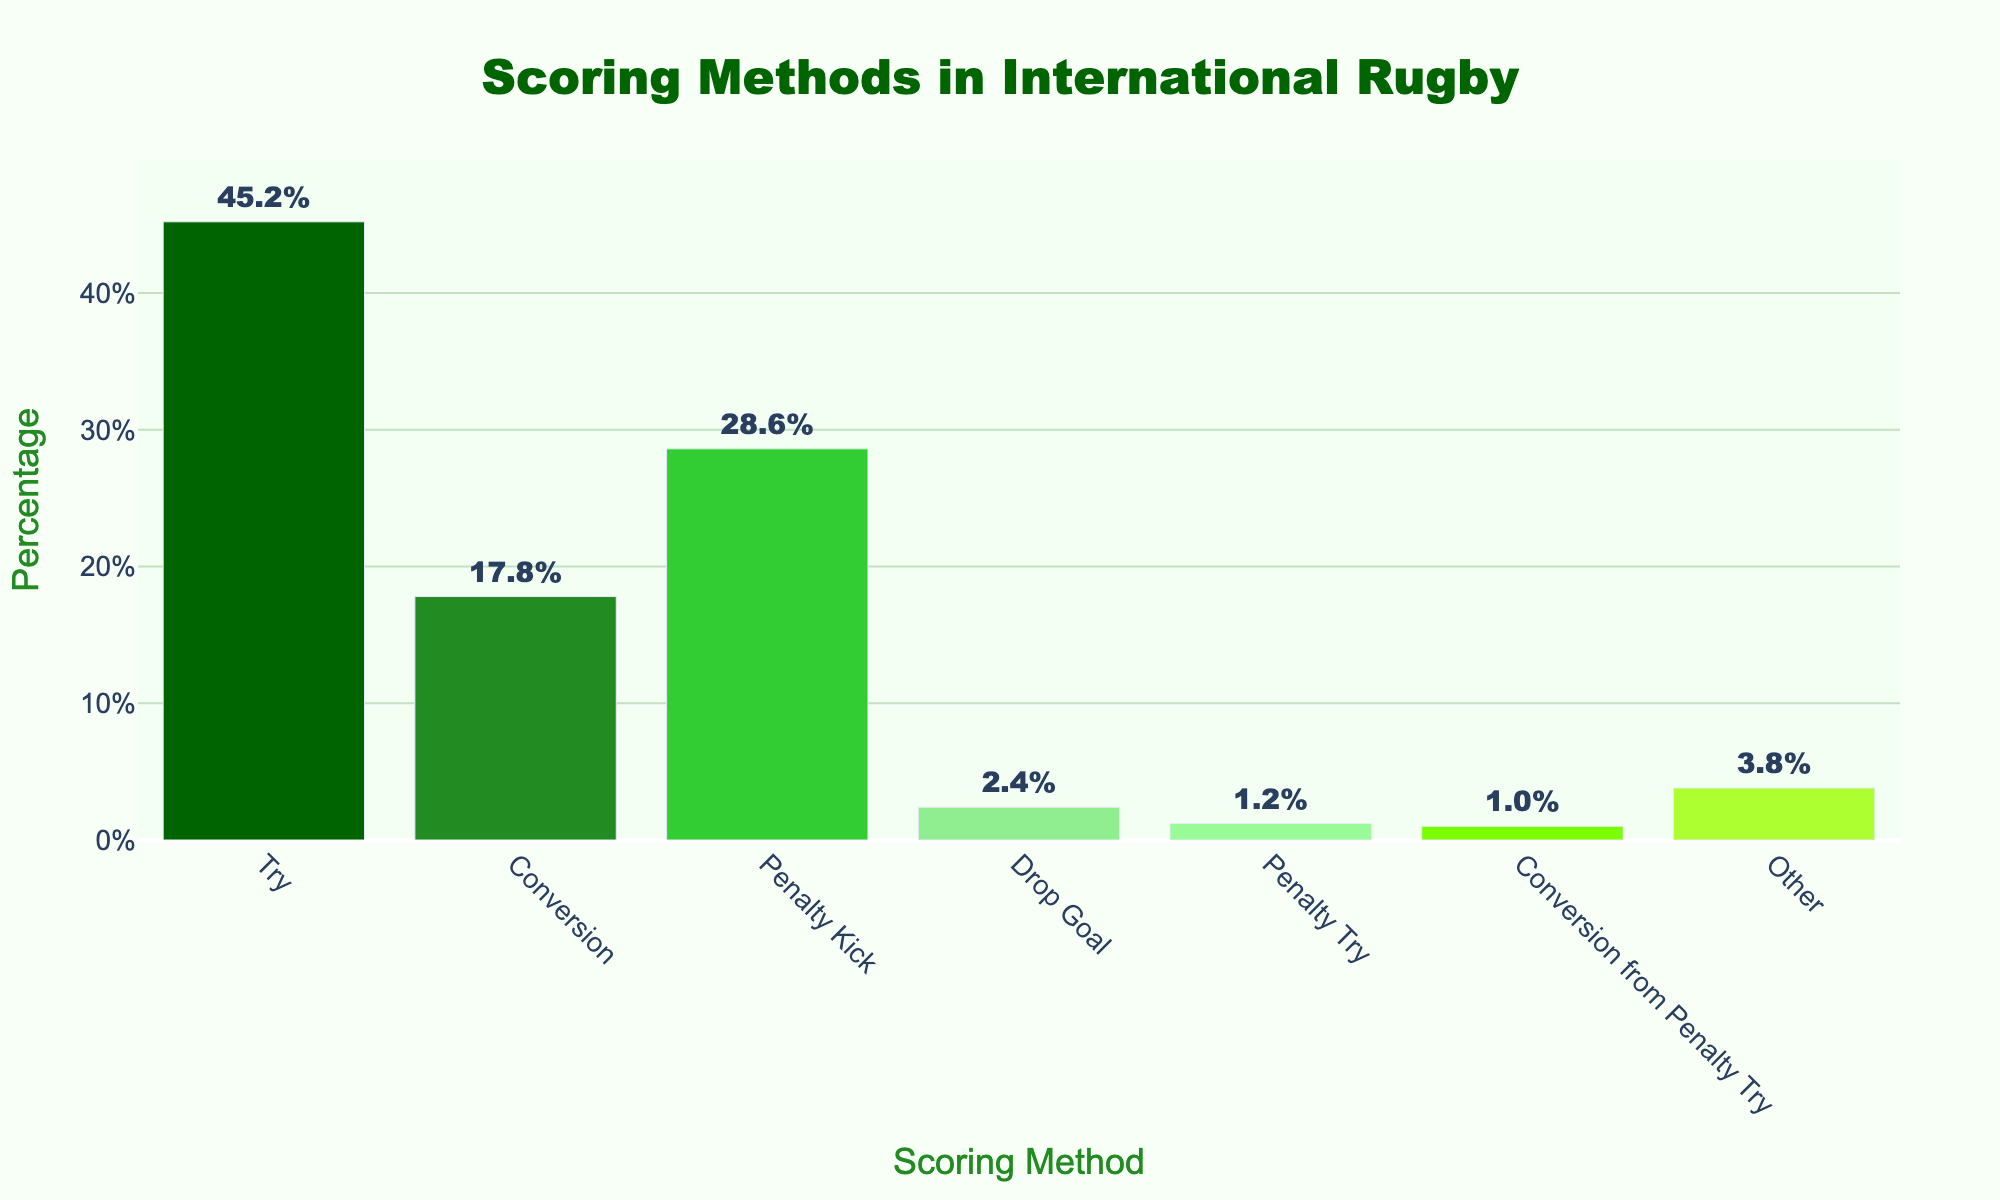Which scoring method contributes the highest percentage of total points? The bar for "Try" is the tallest among all the bars, indicating it has the highest percentage.
Answer: Try What are the combined percentages of Penalty Kick and Drop Goal? The percentage for Penalty Kick is 28.6% and for Drop Goal is 2.4%. Adding them together: 28.6 + 2.4 = 31.0%.
Answer: 31.0% Which scoring method has a lower percentage, a Conversion from Penalty Try or a Penalty Try? The bar for "Conversion from Penalty Try" is shorter than the bar for "Penalty Try," indicating it has a lower percentage.
Answer: Conversion from Penalty Try How much more prevalent are Tries compared to Penalty Kicks? The percentage for Tries is 45.2%, and for Penalty Kicks, it’s 28.6%. Subtracting 28.6 from 45.2 gives: 45.2 - 28.6 = 16.6%.
Answer: 16.6% Rank the scoring methods from highest to lowest percentage. By comparing the heights of the bars, the ranking is: Try, Penalty Kick, Conversion, Other, Drop Goal, Penalty Try, Conversion from Penalty Try.
Answer: Try > Penalty Kick > Conversion > Other > Drop Goal > Penalty Try > Conversion from Penalty Try Which scoring methods account for less than 5% of the total points individually? The percentages less than 5% are for Drop Goal (2.4%), Penalty Try (1.2%), and Conversion from Penalty Try (1.0%).
Answer: Drop Goal, Penalty Try, and Conversion from Penalty Try How does the percentage of Other compare to the percentage of Conversion? The percentage for Other is 3.8%, and for Conversion, it is 17.8%. Other (3.8%) is less than Conversion (17.8%).
Answer: Other is less than Conversion What is the difference between the percentages of Conversion and Penalty Kick? The percentage for Conversion is 17.8%, and for Penalty Kick is 28.6%. Subtracting 17.8 from 28.6 gives: 28.6 - 17.8 = 10.8%.
Answer: 10.8% Which color corresponds to the method with the lowest percentage, and what method is it? The bar for "Conversion from Penalty Try" is the shortest and is colored light green, signifying it has the lowest percentage.
Answer: Light green corresponds to Conversion from Penalty Try If you group Penalty Try and Conversion from Penalty Try together, what is their combined percentage? The percentage for Penalty Try is 1.2% and for Conversion from Penalty Try is 1.0%. Adding them together: 1.2 + 1.0 = 2.2%.
Answer: 2.2% 